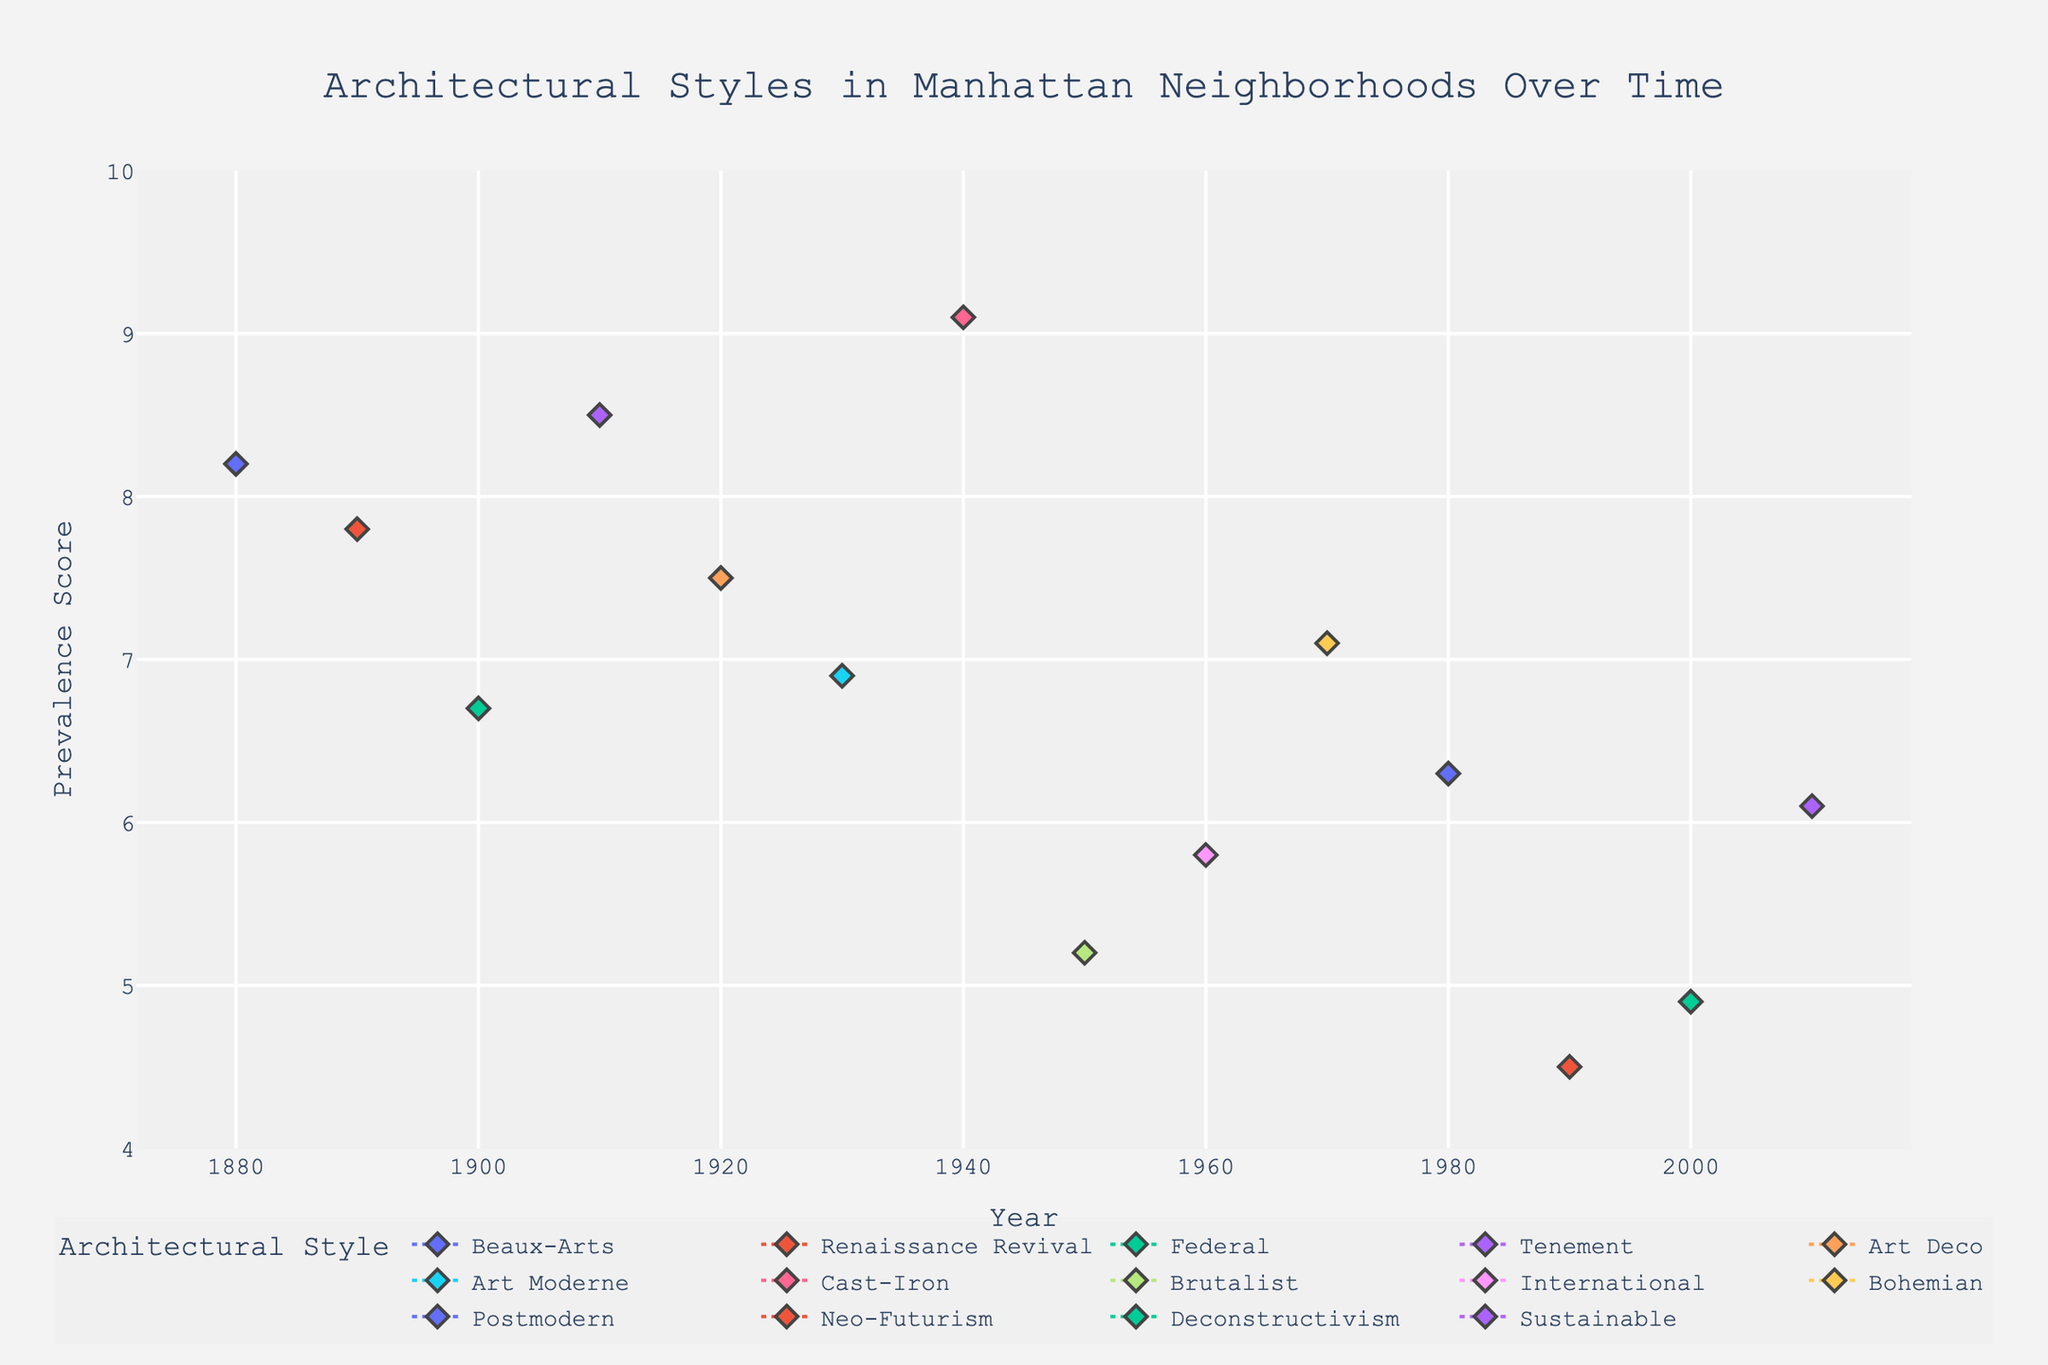Which neighborhood is represented by the highest prevalence score in the year 1940? The plot indicates the neighborhood data points clearly for each year. Locate the 1940 datapoint along the x-axis and find the highest y-value in the year. The highest value in 1940 is 9.1, corresponding to SoHo.
Answer: SoHo What's the difference in prevalence score between the Beaux-Arts style in Upper East Side (1880) and the Tenement style in Lower East Side (1910)? Locate the points for Beaux-Arts in Upper East Side (1880) and Tenement in Lower East Side (1910) along the x-axis. The corresponding y-values are 8.2 and 8.5. Calculate the difference 8.5 - 8.2 = 0.3.
Answer: 0.3 Which architectural style has the earliest appearance in the plot? The plot is sorted by year on the x-axis. The earliest x-value corresponds to the year 1880, which is represented by Beaux-Arts style in Upper East Side.
Answer: Beaux-Arts What is the average prevalence score for the architectural styles in the 1980s and 2000s combined? Identify the prevalence scores for the years 1980 and 2000: 6.3 for Postmodern in 1980 and 4.9 for Deconstructivism in 2000. Calculate the average (6.3 + 4.9) / 2 = 5.6.
Answer: 5.6 How many neighborhoods are represented in the year 1890? The plot shows the labeled points for each year along the x-axis. Only the Upper West Side is indicated for the year 1890, so there is 1 neighborhood.
Answer: 1 Which architectural style shows a prevalence in Greenwich Village and what is the score? Locate the neighborhood name Greenwich Village along the x-axis. The associated style is Federal with a prevalence score of 6.7.
Answer: Federal with a score of 6.7 What is the highest prevalence score observed and which architectural style does it correspond to? The plot shows various prevalence scores along the y-axis. The highest y-value is 9.1, which corresponds to the Cast-Iron style in SoHo (1940).
Answer: Cast-Iron with a score of 9.1 Which two architectural styles have the closest prevalence scores and what are those scores? Locate the scores in the plot and compare them visually. The closest scores are 5.8 for International in Chelsea (1960) and 6.1 for Sustainable in Flatiron District (2010), differing by 0.3.
Answer: International (5.8) and Sustainable (6.1) In which decade does the Bohemian architectural style appear, and in which neighborhood? Locate the Bohemian style point on the plot along the x-axis. It is placed in the 1970s decade and corresponds to East Village.
Answer: 1970s, East Village 